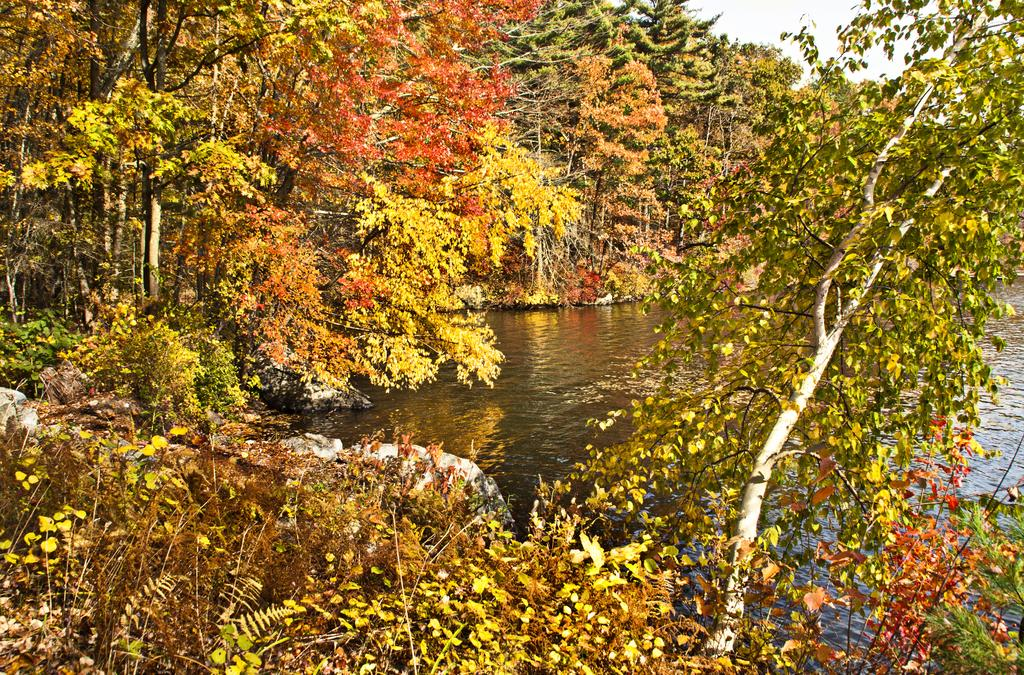What type of natural elements can be seen in the image? There are trees and rocks visible in the image. What else can be seen in the image besides the trees and rocks? There is water visible in the image, as well as the sky. What type of stove is visible in the image? There is no stove present in the image. Can you describe the mother's interaction with the trees in the image? There is no mother or interaction with the trees depicted in the image. 